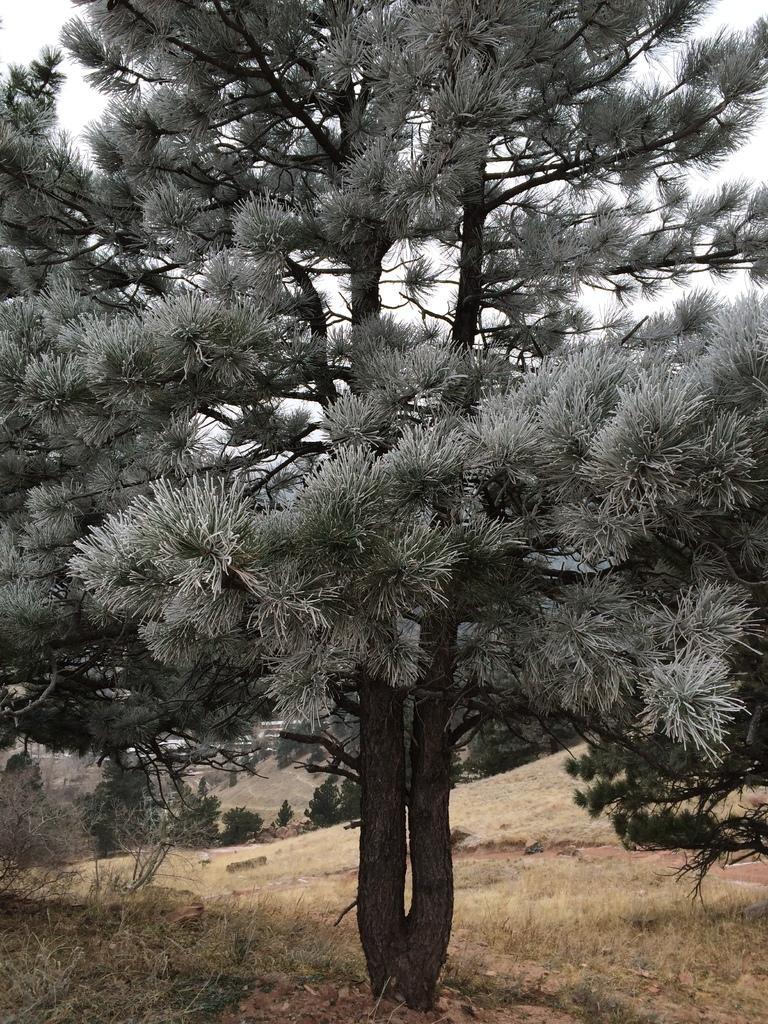Can you describe this image briefly? In this picture we can see trees, grass and in the background we can see the sky. 